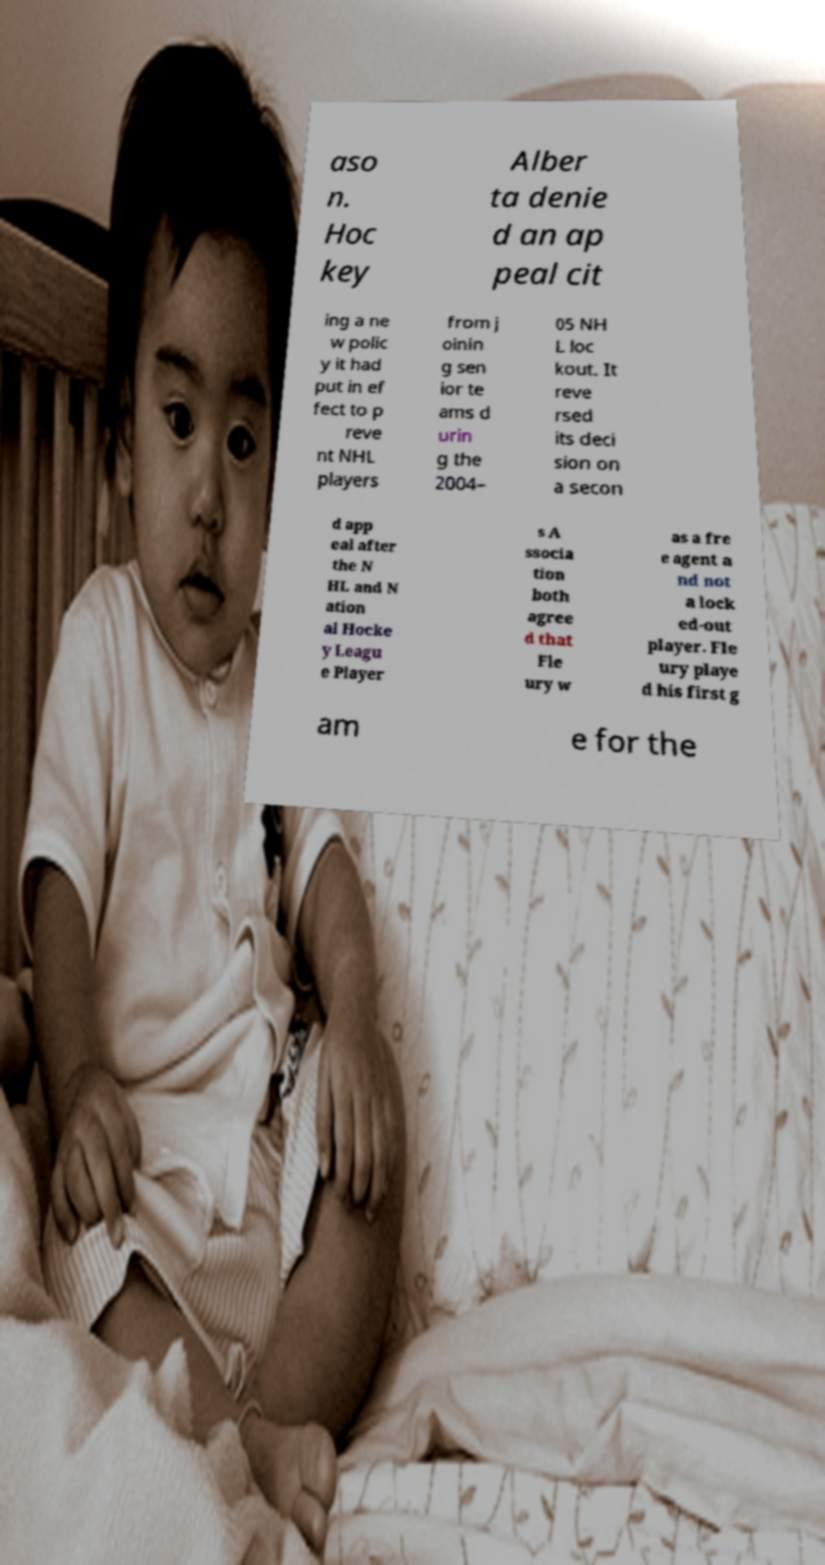Can you accurately transcribe the text from the provided image for me? aso n. Hoc key Alber ta denie d an ap peal cit ing a ne w polic y it had put in ef fect to p reve nt NHL players from j oinin g sen ior te ams d urin g the 2004– 05 NH L loc kout. It reve rsed its deci sion on a secon d app eal after the N HL and N ation al Hocke y Leagu e Player s A ssocia tion both agree d that Fle ury w as a fre e agent a nd not a lock ed-out player. Fle ury playe d his first g am e for the 